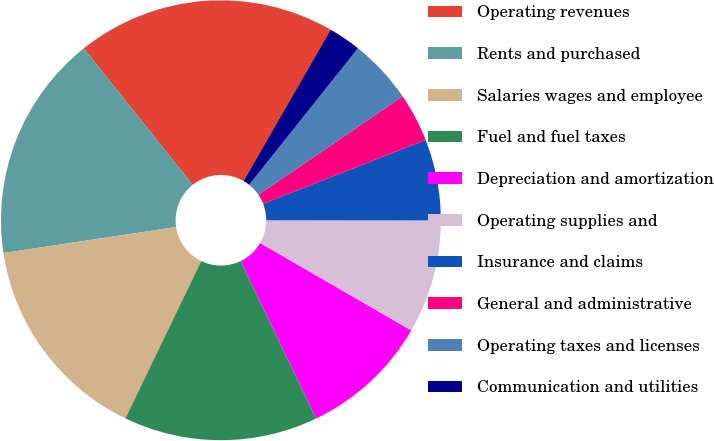<chart> <loc_0><loc_0><loc_500><loc_500><pie_chart><fcel>Operating revenues<fcel>Rents and purchased<fcel>Salaries wages and employee<fcel>Fuel and fuel taxes<fcel>Depreciation and amortization<fcel>Operating supplies and<fcel>Insurance and claims<fcel>General and administrative<fcel>Operating taxes and licenses<fcel>Communication and utilities<nl><fcel>19.04%<fcel>16.66%<fcel>15.47%<fcel>14.28%<fcel>9.52%<fcel>8.34%<fcel>5.96%<fcel>3.58%<fcel>4.77%<fcel>2.39%<nl></chart> 